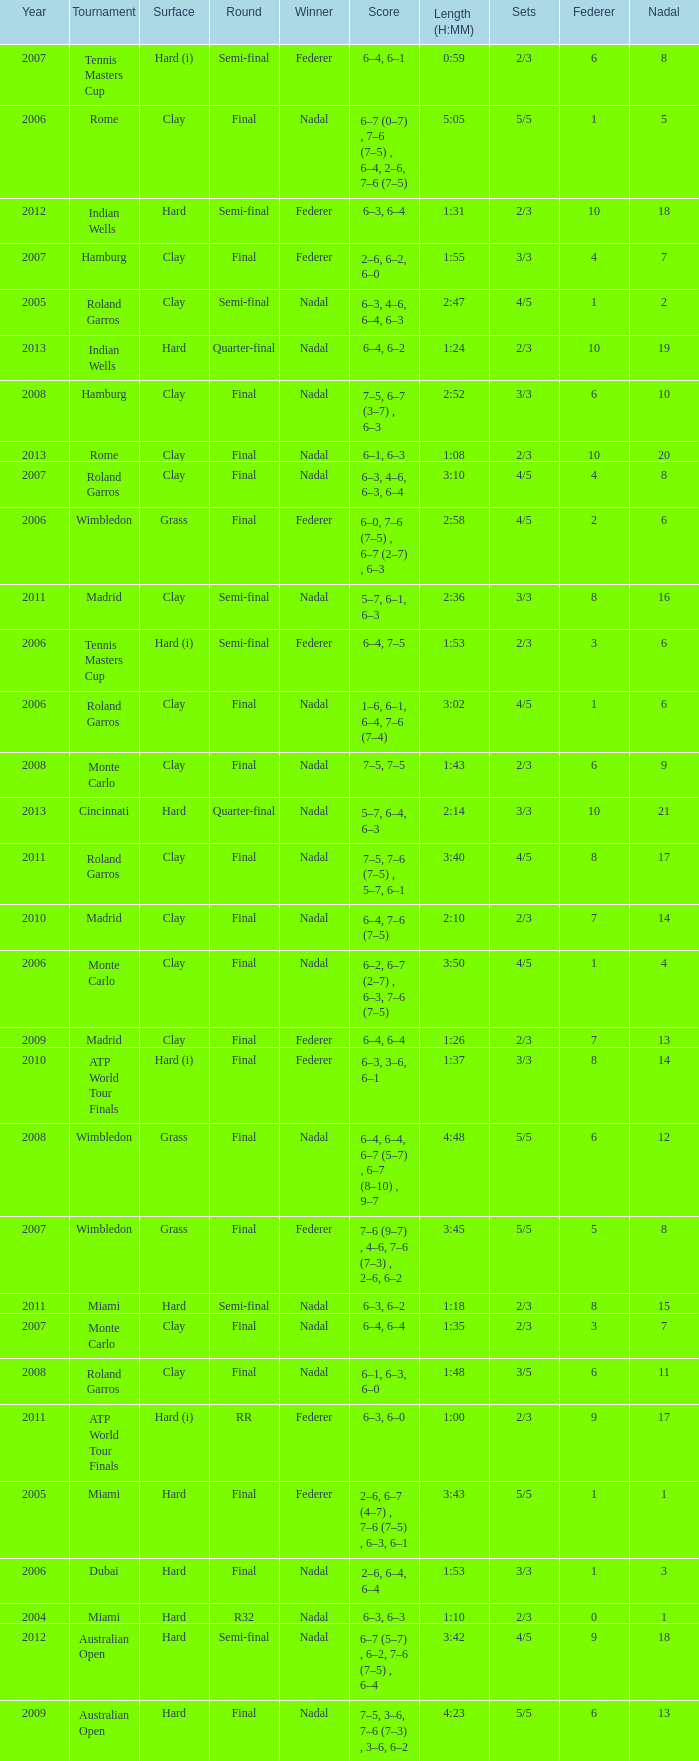Write the full table. {'header': ['Year', 'Tournament', 'Surface', 'Round', 'Winner', 'Score', 'Length (H:MM)', 'Sets', 'Federer', 'Nadal'], 'rows': [['2007', 'Tennis Masters Cup', 'Hard (i)', 'Semi-final', 'Federer', '6–4, 6–1', '0:59', '2/3', '6', '8'], ['2006', 'Rome', 'Clay', 'Final', 'Nadal', '6–7 (0–7) , 7–6 (7–5) , 6–4, 2–6, 7–6 (7–5)', '5:05', '5/5', '1', '5'], ['2012', 'Indian Wells', 'Hard', 'Semi-final', 'Federer', '6–3, 6–4', '1:31', '2/3', '10', '18'], ['2007', 'Hamburg', 'Clay', 'Final', 'Federer', '2–6, 6–2, 6–0', '1:55', '3/3', '4', '7'], ['2005', 'Roland Garros', 'Clay', 'Semi-final', 'Nadal', '6–3, 4–6, 6–4, 6–3', '2:47', '4/5', '1', '2'], ['2013', 'Indian Wells', 'Hard', 'Quarter-final', 'Nadal', '6–4, 6–2', '1:24', '2/3', '10', '19'], ['2008', 'Hamburg', 'Clay', 'Final', 'Nadal', '7–5, 6–7 (3–7) , 6–3', '2:52', '3/3', '6', '10'], ['2013', 'Rome', 'Clay', 'Final', 'Nadal', '6–1, 6–3', '1:08', '2/3', '10', '20'], ['2007', 'Roland Garros', 'Clay', 'Final', 'Nadal', '6–3, 4–6, 6–3, 6–4', '3:10', '4/5', '4', '8'], ['2006', 'Wimbledon', 'Grass', 'Final', 'Federer', '6–0, 7–6 (7–5) , 6–7 (2–7) , 6–3', '2:58', '4/5', '2', '6'], ['2011', 'Madrid', 'Clay', 'Semi-final', 'Nadal', '5–7, 6–1, 6–3', '2:36', '3/3', '8', '16'], ['2006', 'Tennis Masters Cup', 'Hard (i)', 'Semi-final', 'Federer', '6–4, 7–5', '1:53', '2/3', '3', '6'], ['2006', 'Roland Garros', 'Clay', 'Final', 'Nadal', '1–6, 6–1, 6–4, 7–6 (7–4)', '3:02', '4/5', '1', '6'], ['2008', 'Monte Carlo', 'Clay', 'Final', 'Nadal', '7–5, 7–5', '1:43', '2/3', '6', '9'], ['2013', 'Cincinnati', 'Hard', 'Quarter-final', 'Nadal', '5–7, 6–4, 6–3', '2:14', '3/3', '10', '21'], ['2011', 'Roland Garros', 'Clay', 'Final', 'Nadal', '7–5, 7–6 (7–5) , 5–7, 6–1', '3:40', '4/5', '8', '17'], ['2010', 'Madrid', 'Clay', 'Final', 'Nadal', '6–4, 7–6 (7–5)', '2:10', '2/3', '7', '14'], ['2006', 'Monte Carlo', 'Clay', 'Final', 'Nadal', '6–2, 6–7 (2–7) , 6–3, 7–6 (7–5)', '3:50', '4/5', '1', '4'], ['2009', 'Madrid', 'Clay', 'Final', 'Federer', '6–4, 6–4', '1:26', '2/3', '7', '13'], ['2010', 'ATP World Tour Finals', 'Hard (i)', 'Final', 'Federer', '6–3, 3–6, 6–1', '1:37', '3/3', '8', '14'], ['2008', 'Wimbledon', 'Grass', 'Final', 'Nadal', '6–4, 6–4, 6–7 (5–7) , 6–7 (8–10) , 9–7', '4:48', '5/5', '6', '12'], ['2007', 'Wimbledon', 'Grass', 'Final', 'Federer', '7–6 (9–7) , 4–6, 7–6 (7–3) , 2–6, 6–2', '3:45', '5/5', '5', '8'], ['2011', 'Miami', 'Hard', 'Semi-final', 'Nadal', '6–3, 6–2', '1:18', '2/3', '8', '15'], ['2007', 'Monte Carlo', 'Clay', 'Final', 'Nadal', '6–4, 6–4', '1:35', '2/3', '3', '7'], ['2008', 'Roland Garros', 'Clay', 'Final', 'Nadal', '6–1, 6–3, 6–0', '1:48', '3/5', '6', '11'], ['2011', 'ATP World Tour Finals', 'Hard (i)', 'RR', 'Federer', '6–3, 6–0', '1:00', '2/3', '9', '17'], ['2005', 'Miami', 'Hard', 'Final', 'Federer', '2–6, 6–7 (4–7) , 7–6 (7–5) , 6–3, 6–1', '3:43', '5/5', '1', '1'], ['2006', 'Dubai', 'Hard', 'Final', 'Nadal', '2–6, 6–4, 6–4', '1:53', '3/3', '1', '3'], ['2004', 'Miami', 'Hard', 'R32', 'Nadal', '6–3, 6–3', '1:10', '2/3', '0', '1'], ['2012', 'Australian Open', 'Hard', 'Semi-final', 'Nadal', '6–7 (5–7) , 6–2, 7–6 (7–5) , 6–4', '3:42', '4/5', '9', '18'], ['2009', 'Australian Open', 'Hard', 'Final', 'Nadal', '7–5, 3–6, 7–6 (7–3) , 3–6, 6–2', '4:23', '5/5', '6', '13']]} What was the nadal in Miami in the final round? 1.0. 